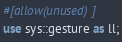<code> <loc_0><loc_0><loc_500><loc_500><_Rust_>#[allow(unused)]
use sys::gesture as ll;
</code> 